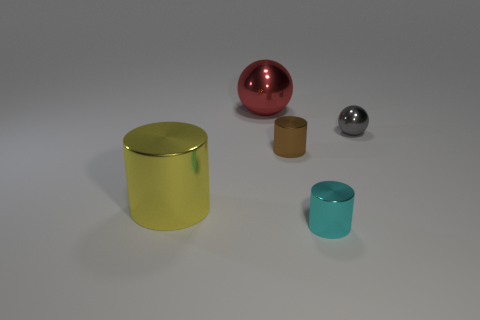What is the color of the big metallic thing that is the same shape as the small gray metal object?
Provide a short and direct response. Red. There is a big yellow object; what shape is it?
Ensure brevity in your answer.  Cylinder. There is a shiny object that is behind the small brown cylinder and right of the big red metallic ball; what is its shape?
Provide a short and direct response. Sphere. The shiny cylinder to the left of the brown cylinder is what color?
Make the answer very short. Yellow. Are there any other things that are the same color as the big cylinder?
Ensure brevity in your answer.  No. Do the gray sphere and the red metal object have the same size?
Your response must be concise. No. What size is the metallic thing that is behind the small brown object and on the left side of the tiny gray metallic thing?
Offer a terse response. Large. How many cyan cylinders are made of the same material as the gray ball?
Your response must be concise. 1. What is the color of the small sphere?
Your response must be concise. Gray. There is a big object behind the gray sphere; is its shape the same as the gray shiny object?
Provide a short and direct response. Yes. 